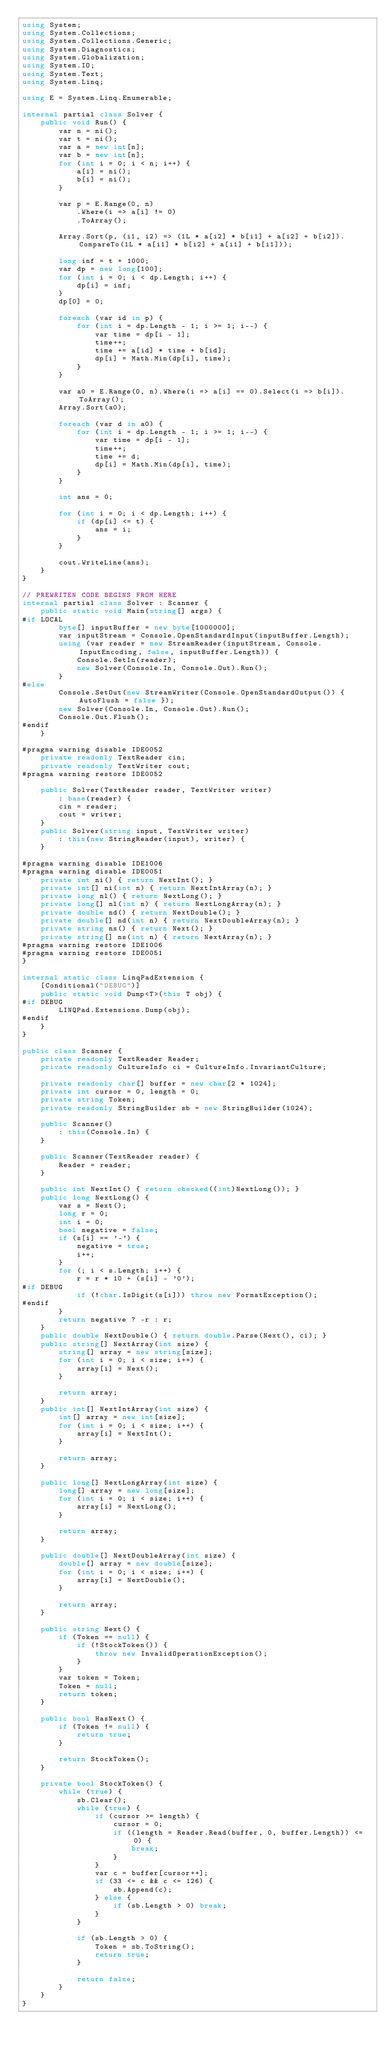<code> <loc_0><loc_0><loc_500><loc_500><_C#_>using System;
using System.Collections;
using System.Collections.Generic;
using System.Diagnostics;
using System.Globalization;
using System.IO;
using System.Text;
using System.Linq;

using E = System.Linq.Enumerable;

internal partial class Solver {
    public void Run() {
        var n = ni();
        var t = ni();
        var a = new int[n];
        var b = new int[n];
        for (int i = 0; i < n; i++) {
            a[i] = ni();
            b[i] = ni();
        }

        var p = E.Range(0, n)
            .Where(i => a[i] != 0)
            .ToArray();

        Array.Sort(p, (i1, i2) => (1L * a[i2] * b[i1] + a[i2] + b[i2]).CompareTo(1L * a[i1] * b[i2] + a[i1] + b[i1]));

        long inf = t + 1000;
        var dp = new long[100];
        for (int i = 0; i < dp.Length; i++) {
            dp[i] = inf;
        }
        dp[0] = 0;

        foreach (var id in p) {
            for (int i = dp.Length - 1; i >= 1; i--) {
                var time = dp[i - 1];
                time++;
                time += a[id] * time + b[id];
                dp[i] = Math.Min(dp[i], time);
            }
        }

        var a0 = E.Range(0, n).Where(i => a[i] == 0).Select(i => b[i]).ToArray();
        Array.Sort(a0);

        foreach (var d in a0) {
            for (int i = dp.Length - 1; i >= 1; i--) {
                var time = dp[i - 1];
                time++;
                time += d;
                dp[i] = Math.Min(dp[i], time);
            }
        }

        int ans = 0;

        for (int i = 0; i < dp.Length; i++) {
            if (dp[i] <= t) {
                ans = i;
            }
        }

        cout.WriteLine(ans);
    }
}

// PREWRITEN CODE BEGINS FROM HERE
internal partial class Solver : Scanner {
    public static void Main(string[] args) {
#if LOCAL
        byte[] inputBuffer = new byte[1000000];
        var inputStream = Console.OpenStandardInput(inputBuffer.Length);
        using (var reader = new StreamReader(inputStream, Console.InputEncoding, false, inputBuffer.Length)) {
            Console.SetIn(reader);
            new Solver(Console.In, Console.Out).Run();
        }
#else
        Console.SetOut(new StreamWriter(Console.OpenStandardOutput()) { AutoFlush = false });
        new Solver(Console.In, Console.Out).Run();
        Console.Out.Flush();
#endif
    }

#pragma warning disable IDE0052
    private readonly TextReader cin;
    private readonly TextWriter cout;
#pragma warning restore IDE0052

    public Solver(TextReader reader, TextWriter writer)
        : base(reader) {
        cin = reader;
        cout = writer;
    }
    public Solver(string input, TextWriter writer)
        : this(new StringReader(input), writer) {
    }

#pragma warning disable IDE1006
#pragma warning disable IDE0051
    private int ni() { return NextInt(); }
    private int[] ni(int n) { return NextIntArray(n); }
    private long nl() { return NextLong(); }
    private long[] nl(int n) { return NextLongArray(n); }
    private double nd() { return NextDouble(); }
    private double[] nd(int n) { return NextDoubleArray(n); }
    private string ns() { return Next(); }
    private string[] ns(int n) { return NextArray(n); }
#pragma warning restore IDE1006
#pragma warning restore IDE0051
}

internal static class LinqPadExtension {
    [Conditional("DEBUG")]
    public static void Dump<T>(this T obj) {
#if DEBUG
        LINQPad.Extensions.Dump(obj);
#endif
    }
}

public class Scanner {
    private readonly TextReader Reader;
    private readonly CultureInfo ci = CultureInfo.InvariantCulture;

    private readonly char[] buffer = new char[2 * 1024];
    private int cursor = 0, length = 0;
    private string Token;
    private readonly StringBuilder sb = new StringBuilder(1024);

    public Scanner()
        : this(Console.In) {
    }

    public Scanner(TextReader reader) {
        Reader = reader;
    }

    public int NextInt() { return checked((int)NextLong()); }
    public long NextLong() {
        var s = Next();
        long r = 0;
        int i = 0;
        bool negative = false;
        if (s[i] == '-') {
            negative = true;
            i++;
        }
        for (; i < s.Length; i++) {
            r = r * 10 + (s[i] - '0');
#if DEBUG
            if (!char.IsDigit(s[i])) throw new FormatException();
#endif
        }
        return negative ? -r : r;
    }
    public double NextDouble() { return double.Parse(Next(), ci); }
    public string[] NextArray(int size) {
        string[] array = new string[size];
        for (int i = 0; i < size; i++) {
            array[i] = Next();
        }

        return array;
    }
    public int[] NextIntArray(int size) {
        int[] array = new int[size];
        for (int i = 0; i < size; i++) {
            array[i] = NextInt();
        }

        return array;
    }

    public long[] NextLongArray(int size) {
        long[] array = new long[size];
        for (int i = 0; i < size; i++) {
            array[i] = NextLong();
        }

        return array;
    }

    public double[] NextDoubleArray(int size) {
        double[] array = new double[size];
        for (int i = 0; i < size; i++) {
            array[i] = NextDouble();
        }

        return array;
    }

    public string Next() {
        if (Token == null) {
            if (!StockToken()) {
                throw new InvalidOperationException();
            }
        }
        var token = Token;
        Token = null;
        return token;
    }

    public bool HasNext() {
        if (Token != null) {
            return true;
        }

        return StockToken();
    }

    private bool StockToken() {
        while (true) {
            sb.Clear();
            while (true) {
                if (cursor >= length) {
                    cursor = 0;
                    if ((length = Reader.Read(buffer, 0, buffer.Length)) <= 0) {
                        break;
                    }
                }
                var c = buffer[cursor++];
                if (33 <= c && c <= 126) {
                    sb.Append(c);
                } else {
                    if (sb.Length > 0) break;
                }
            }

            if (sb.Length > 0) {
                Token = sb.ToString();
                return true;
            }

            return false;
        }
    }
}</code> 